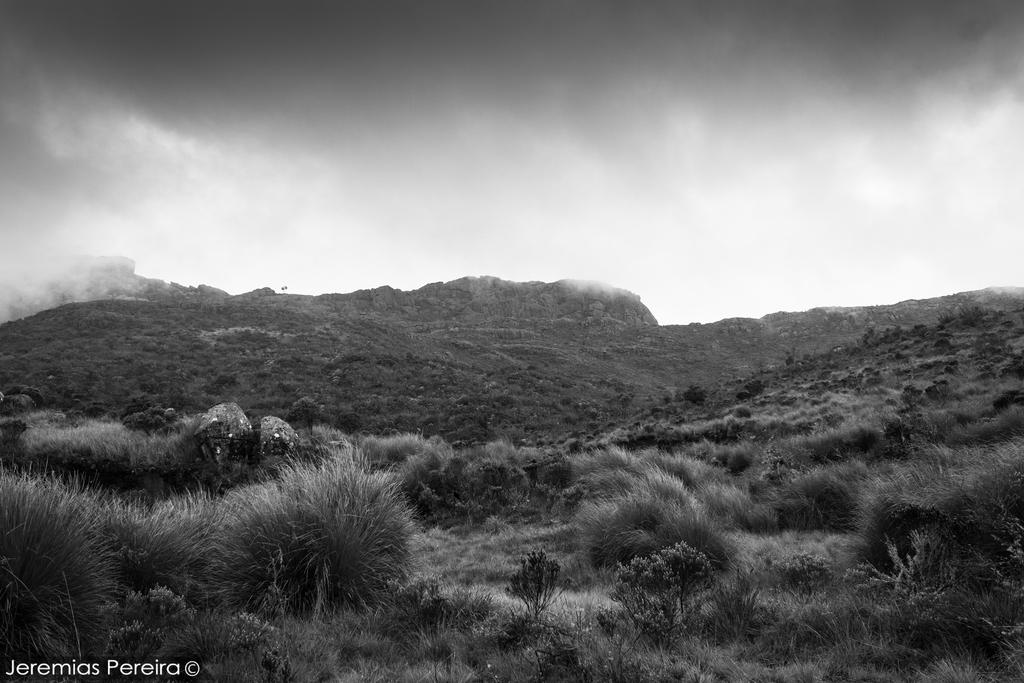What is the color scheme of the image? The image is in black and white. What can be seen on the hill in the image? There are plants on a hill in the image. Where is the text located in the image? The text is in the bottom left of the image. What is visible at the top of the image? There is a sky visible at the top of the image. Is there a scarecrow standing among the plants on the hill in the image? There is no scarecrow present in the image. Can you tell me how many attempts were made to create the image? The number of attempts made to create the image is not visible or mentioned in the image. 